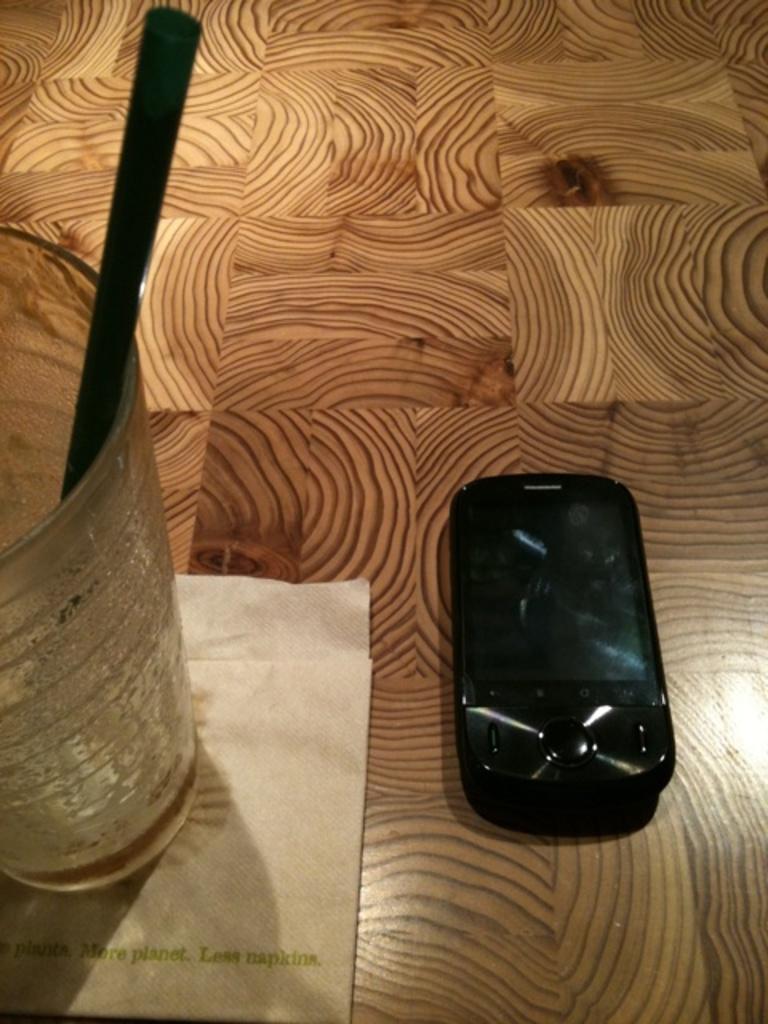What does it say on the napkin beneath the glass?
Offer a terse response. More planet less napkins. 